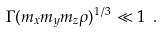<formula> <loc_0><loc_0><loc_500><loc_500>\Gamma ( m _ { x } m _ { y } m _ { z } \rho ) ^ { 1 / 3 } \ll 1 \ .</formula> 